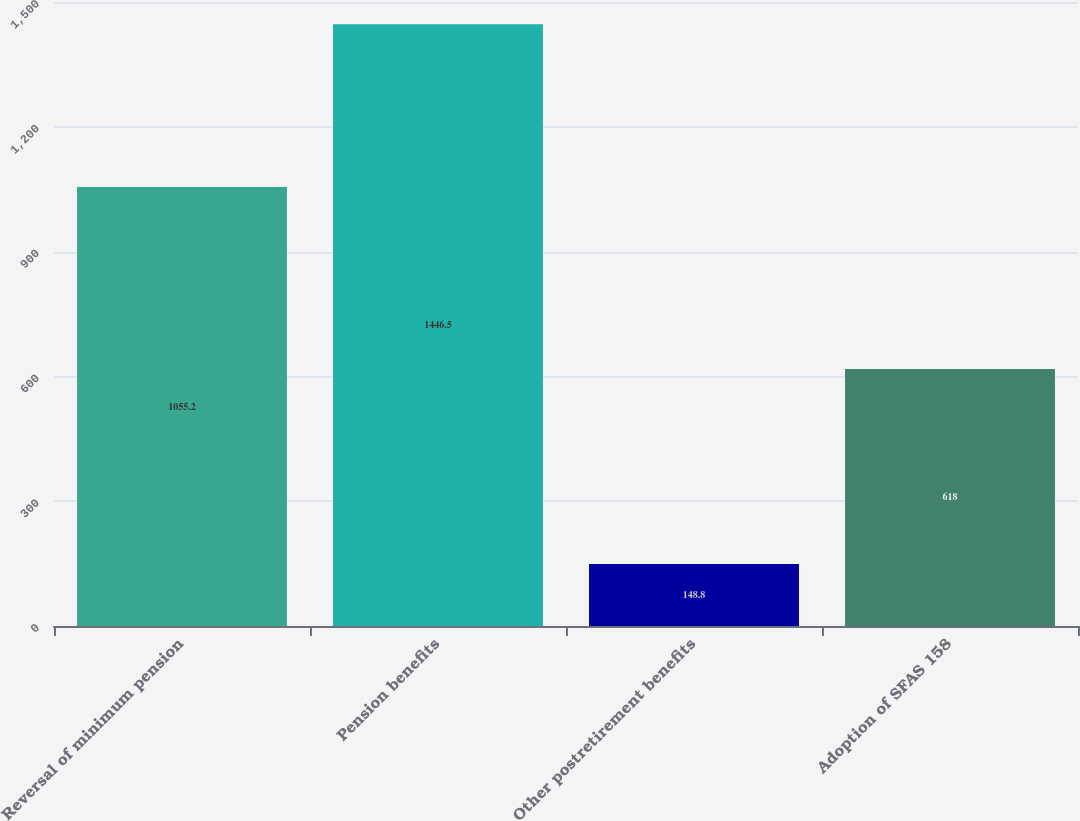Convert chart to OTSL. <chart><loc_0><loc_0><loc_500><loc_500><bar_chart><fcel>Reversal of minimum pension<fcel>Pension benefits<fcel>Other postretirement benefits<fcel>Adoption of SFAS 158<nl><fcel>1055.2<fcel>1446.5<fcel>148.8<fcel>618<nl></chart> 